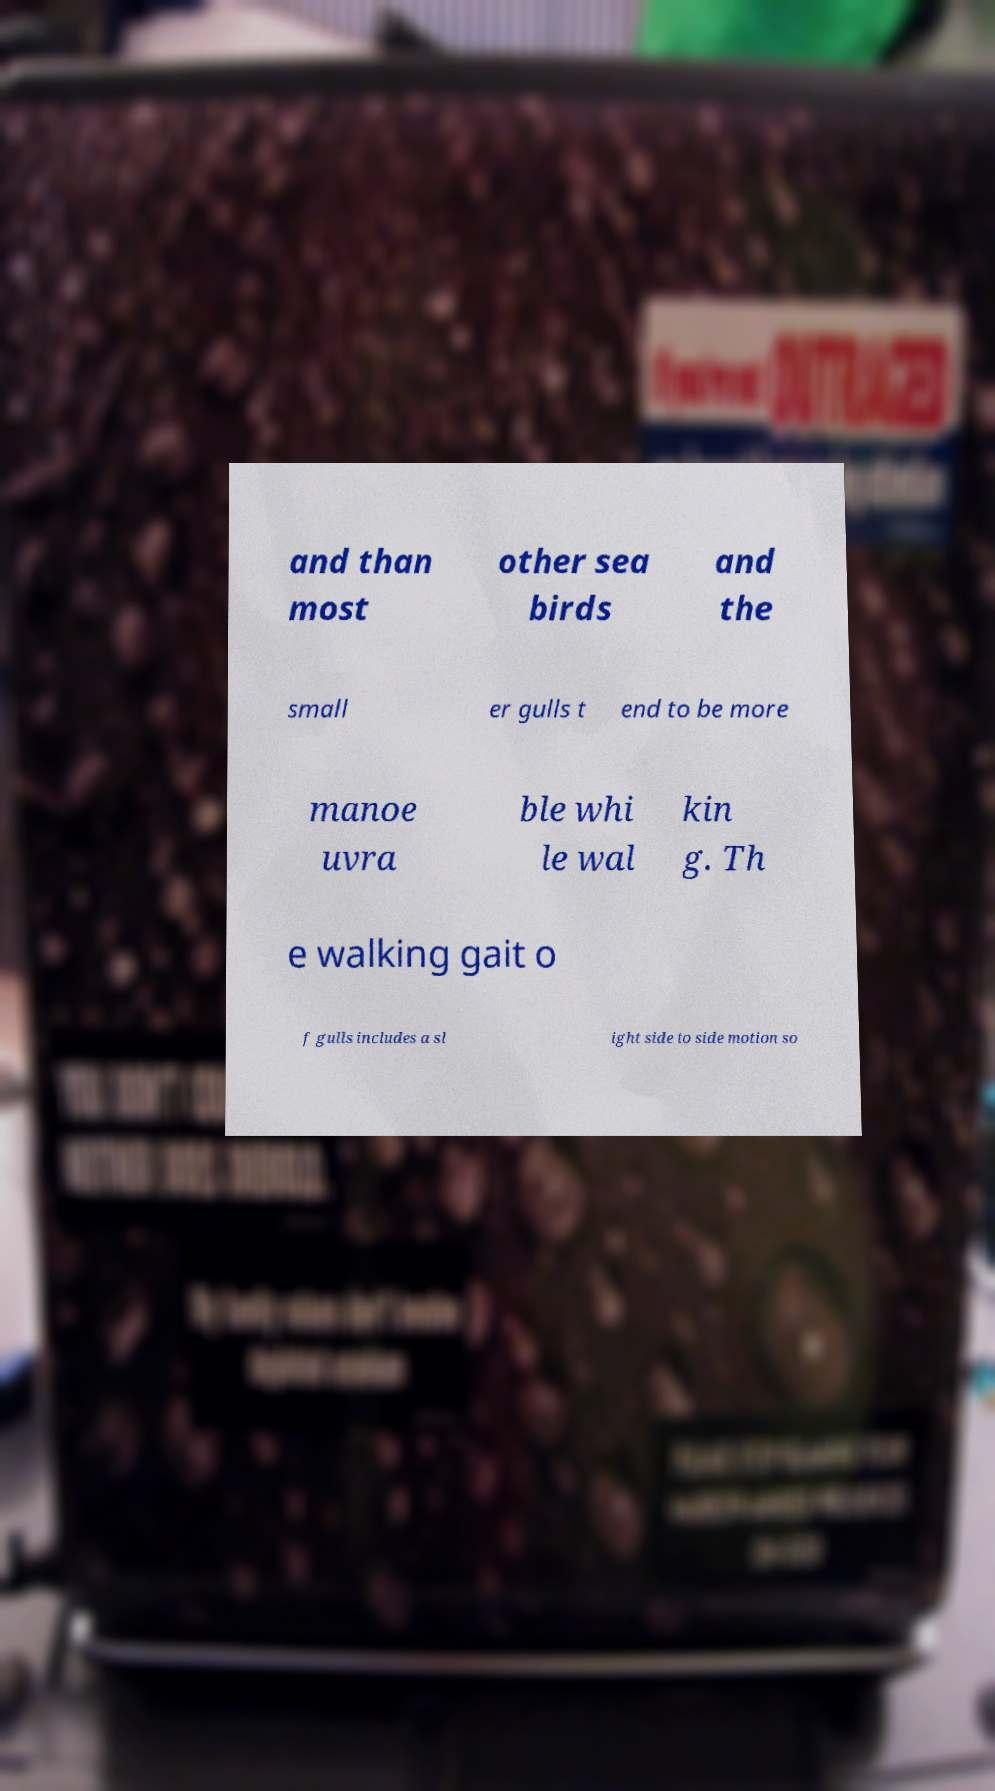Can you read and provide the text displayed in the image?This photo seems to have some interesting text. Can you extract and type it out for me? and than most other sea birds and the small er gulls t end to be more manoe uvra ble whi le wal kin g. Th e walking gait o f gulls includes a sl ight side to side motion so 